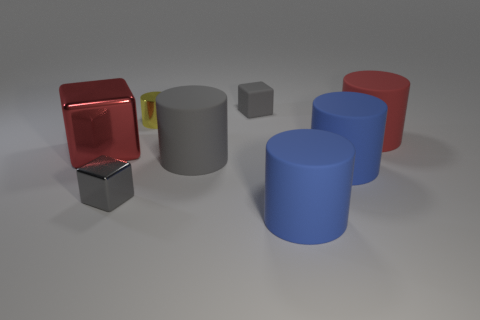Are there more yellow metallic cylinders than metallic objects?
Your response must be concise. No. There is a big block that is on the left side of the tiny gray rubber block; what number of small blocks are behind it?
Offer a terse response. 1. How many objects are either rubber things behind the small cylinder or large purple things?
Ensure brevity in your answer.  1. Are there any other objects of the same shape as the small yellow shiny thing?
Provide a short and direct response. Yes. What is the shape of the blue matte thing left of the blue rubber thing that is behind the small gray metal cube?
Offer a terse response. Cylinder. What number of cylinders are large red objects or large gray metallic objects?
Provide a succinct answer. 1. There is a big cylinder that is the same color as the matte cube; what is its material?
Make the answer very short. Rubber. Do the large red object to the right of the large gray matte object and the matte thing behind the yellow object have the same shape?
Make the answer very short. No. What is the color of the cylinder that is to the left of the rubber cube and in front of the small yellow shiny cylinder?
Offer a terse response. Gray. Does the tiny matte object have the same color as the shiny block that is in front of the gray rubber cylinder?
Provide a short and direct response. Yes. 